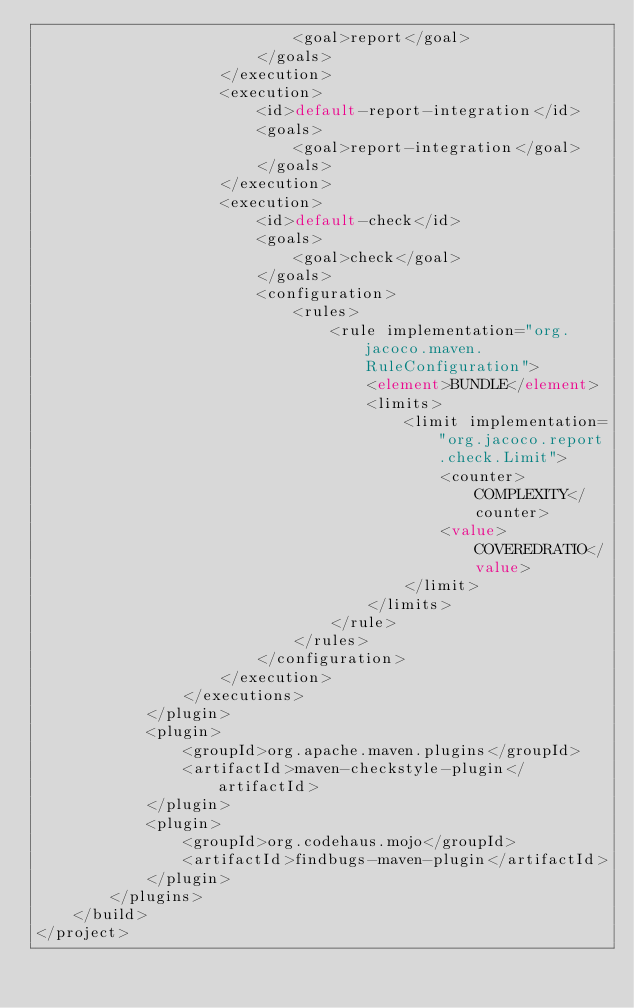<code> <loc_0><loc_0><loc_500><loc_500><_XML_>                            <goal>report</goal>
                        </goals>
                    </execution>
                    <execution>
                        <id>default-report-integration</id>
                        <goals>
                            <goal>report-integration</goal>
                        </goals>
                    </execution>
                    <execution>
                        <id>default-check</id>
                        <goals>
                            <goal>check</goal>
                        </goals>
                        <configuration>
                            <rules>
                                <rule implementation="org.jacoco.maven.RuleConfiguration">
                                    <element>BUNDLE</element>
                                    <limits>
                                        <limit implementation="org.jacoco.report.check.Limit">
                                            <counter>COMPLEXITY</counter>
                                            <value>COVEREDRATIO</value>
                                        </limit>
                                    </limits>
                                </rule>
                            </rules>
                        </configuration>
                    </execution>
                </executions>
            </plugin>
            <plugin>
                <groupId>org.apache.maven.plugins</groupId>
                <artifactId>maven-checkstyle-plugin</artifactId>
            </plugin>
            <plugin>
                <groupId>org.codehaus.mojo</groupId>
                <artifactId>findbugs-maven-plugin</artifactId>
            </plugin>
        </plugins>
    </build>
</project>
</code> 